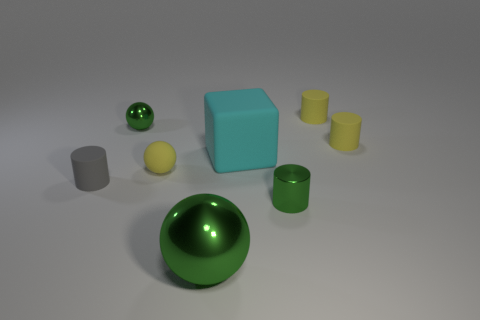Which objects in the picture seem to have a matte surface, and which ones are more reflective? In the image, the blue cube and the yellow cylinders have a matte surface, as indicated by their diffused reflections and more subdued light interaction. Conversely, the gray cylinder, the green sphere and bowl, and the small yellow sphere have more reflective surfaces, showing sharper highlights and clear reflections. How does this affect the perception of the materials? The varied surface textures help to identify the materials: matte surfaces suggest a non-metallic, possibly plastic or painted material, while reflective surfaces suggest a polished metal or a smooth, varnished material, leading to a richer visual experience and an easy differentiation between the objects. 